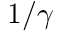<formula> <loc_0><loc_0><loc_500><loc_500>1 / \gamma</formula> 